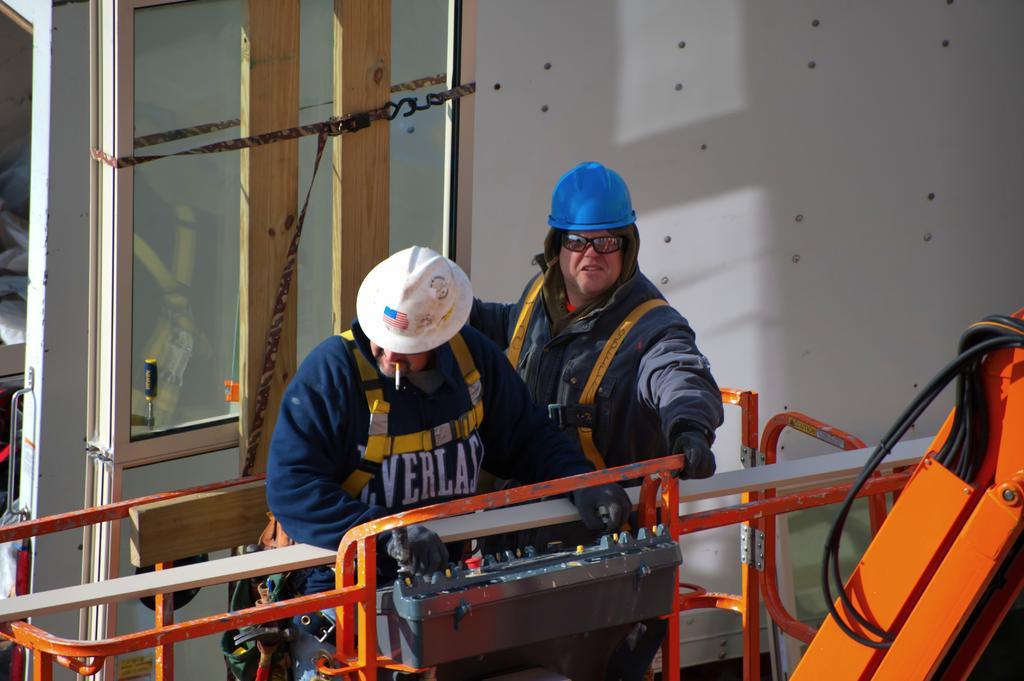Can you describe this image briefly? In this picture there is a person standing and holding the object and there is a person standing. In the foreground there is a crane. At the back there is a reflection of a crane on the mirror and there is a wall. On the right side of the image there are wires. 